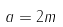Convert formula to latex. <formula><loc_0><loc_0><loc_500><loc_500>a = 2 m</formula> 